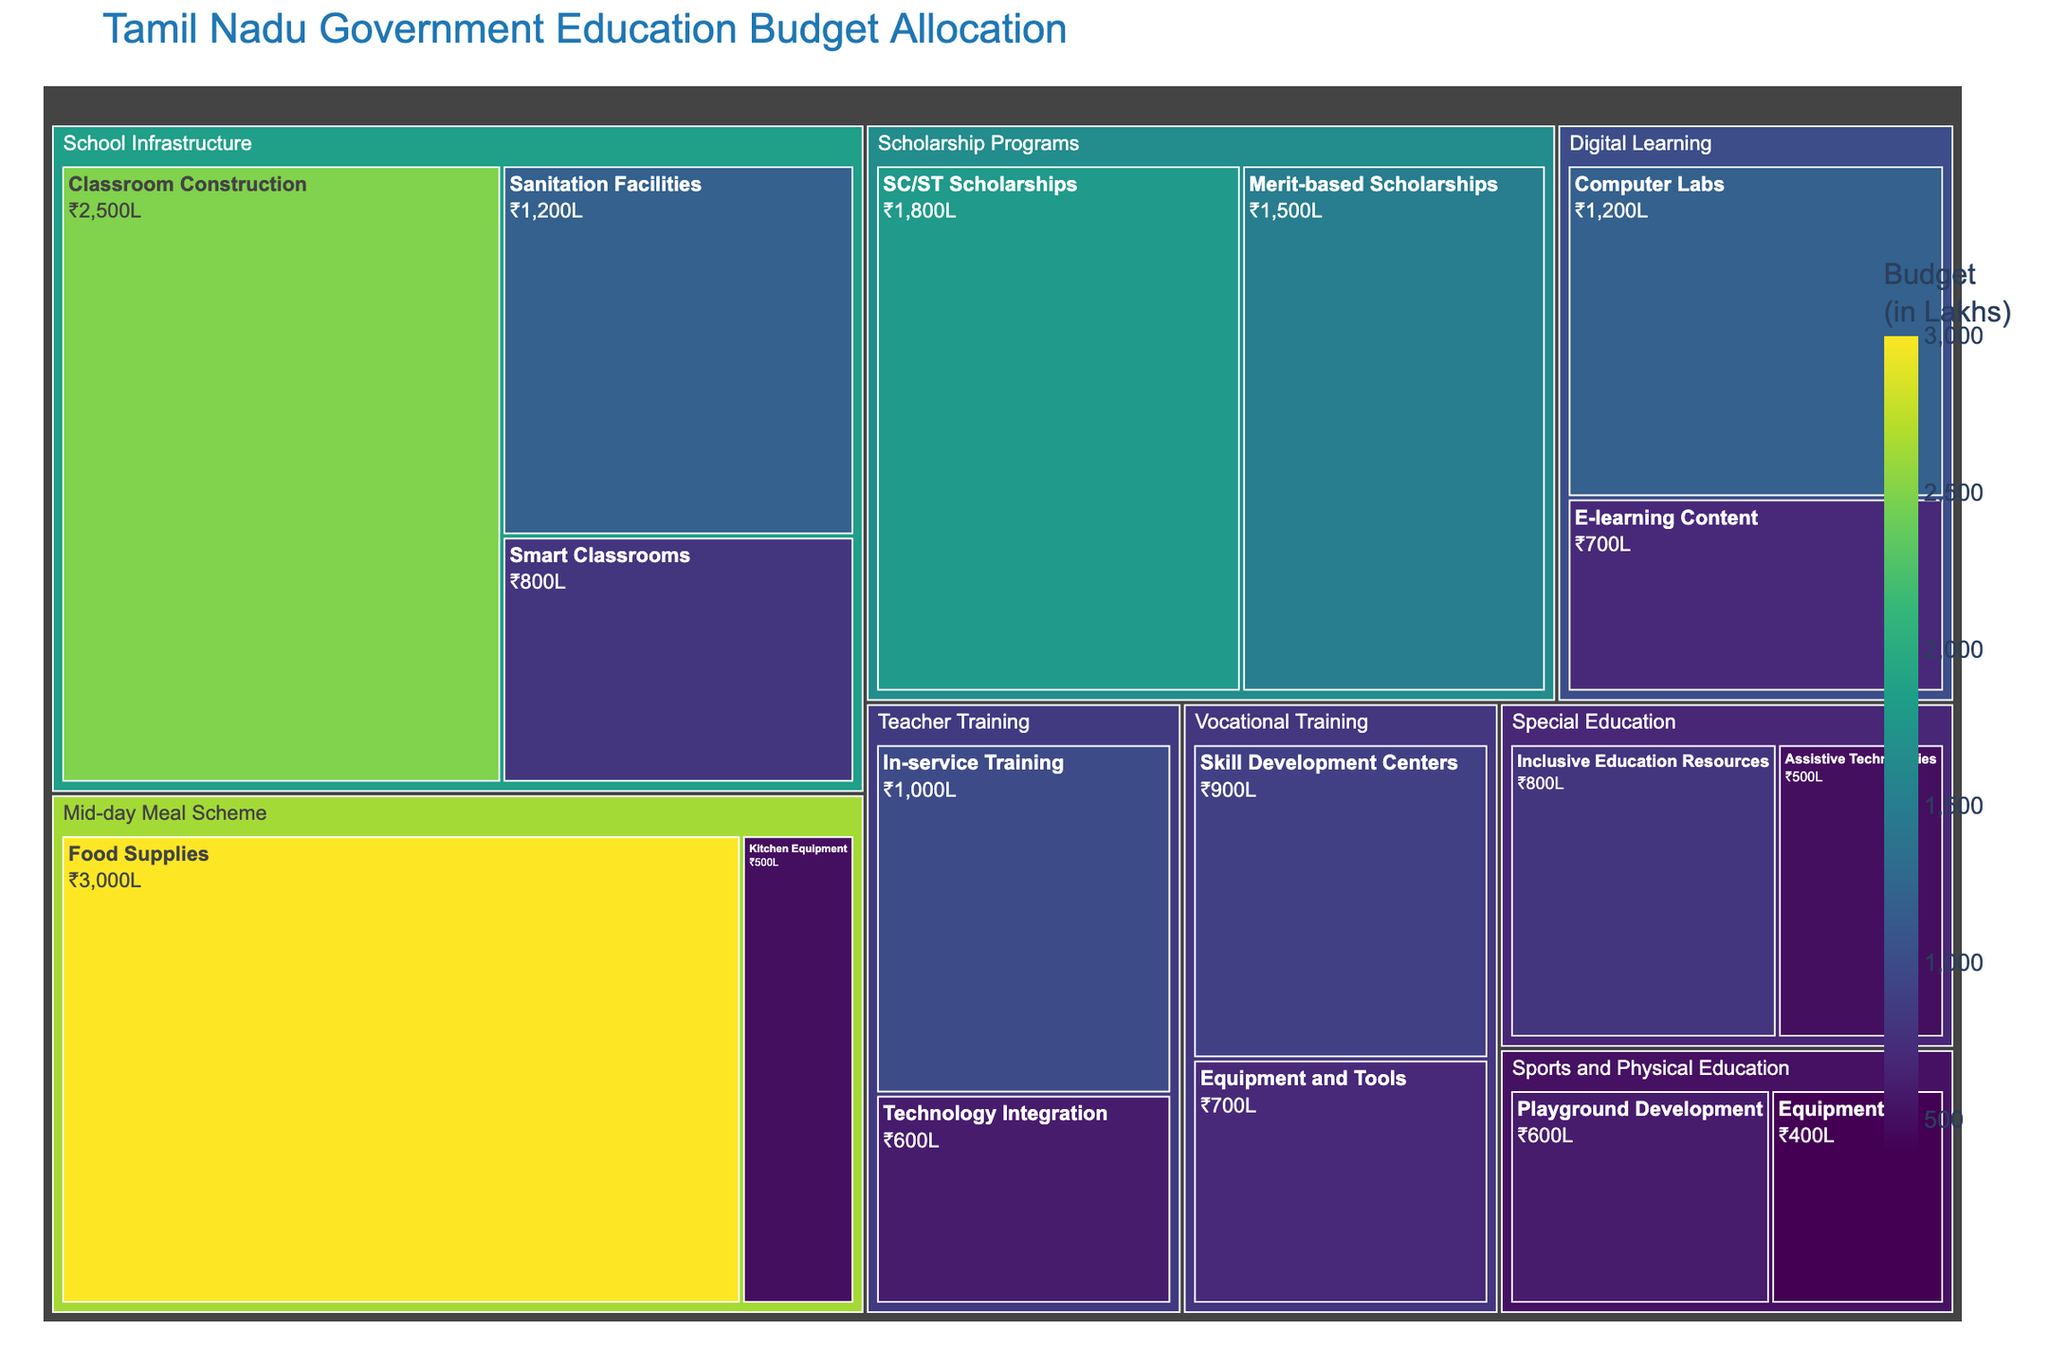What is the total budget allocated for the Mid-day Meal Scheme? To find the total budget for the Mid-day Meal Scheme, sum the values for "Food Supplies" and "Kitchen Equipment" within this category. The values are 3000 Lakhs and 500 Lakhs respectively, so the total is 3000 + 500 = 3500 Lakhs.
Answer: 3500 Lakhs Which subcategory under Digital Learning has a higher budget allocation, Computer Labs or E-learning Content? To compare the budget allocations, look at the values for "Computer Labs" and "E-learning Content" under Digital Learning. "Computer Labs" has an allocation of 1200 Lakhs, while "E-learning Content" has 700 Lakhs. 1200 Lakhs is higher than 700 Lakhs.
Answer: Computer Labs What percentage of the total budget is allocated to School Infrastructure? First, sum the total budget for all categories by adding the values of all subcategories. This sum is 2500 + 1200 + 800 + 3000 + 500 + 1000 + 600 + 1500 + 1800 + 1200 + 700 + 400 + 600 + 800 + 500 + 900 + 700 = 19200 Lakhs. The total for School Infrastructure is 2500 + 1200 + 800 = 4500 Lakhs. The percentage is (4500 / 19200) * 100 ≈ 23.44%.
Answer: 23.44% How much more budget is allocated to Merit-based Scholarships compared to Inclusive Education Resources? The budget for Merit-based Scholarships is 1500 Lakhs and for Inclusive Education Resources is 800 Lakhs. The difference is 1500 - 800 = 700 Lakhs.
Answer: 700 Lakhs What is the combined budget for Technology Integration and Skill Development Centers? Add the values of Technology Integration under Teacher Training and Skill Development Centers under Vocational Training. These values are 600 Lakhs and 900 Lakhs respectively, so the combined budget is 600 + 900 = 1500 Lakhs.
Answer: 1500 Lakhs Is the budget for Classroom Construction more than the total budget for Special Education? The budget for Classroom Construction is 2500 Lakhs. The total budget for Special Education is 800 + 500 = 1300 Lakhs. 2500 Lakhs is more than 1300 Lakhs.
Answer: Yes Which subcategory under Scholarship Programs has a higher budget allocation? Compare the values for "Merit-based Scholarships" and "SC/ST Scholarships" under Scholarship Programs. "Merit-based Scholarships" has a budget of 1500 Lakhs, while "SC/ST Scholarships" has 1800 Lakhs. 1800 Lakhs is higher than 1500 Lakhs.
Answer: SC/ST Scholarships What is the total budget for categories linked to infrastructure (School Infrastructure and Playground Development)? Calculate the total budget for School Infrastructure by summing the values of its subcategories (2500 + 1200 + 800 = 4500 Lakhs). Add the Playground Development value (600 Lakhs). The combined total is 4500 + 600 = 5100 Lakhs.
Answer: 5100 Lakhs 